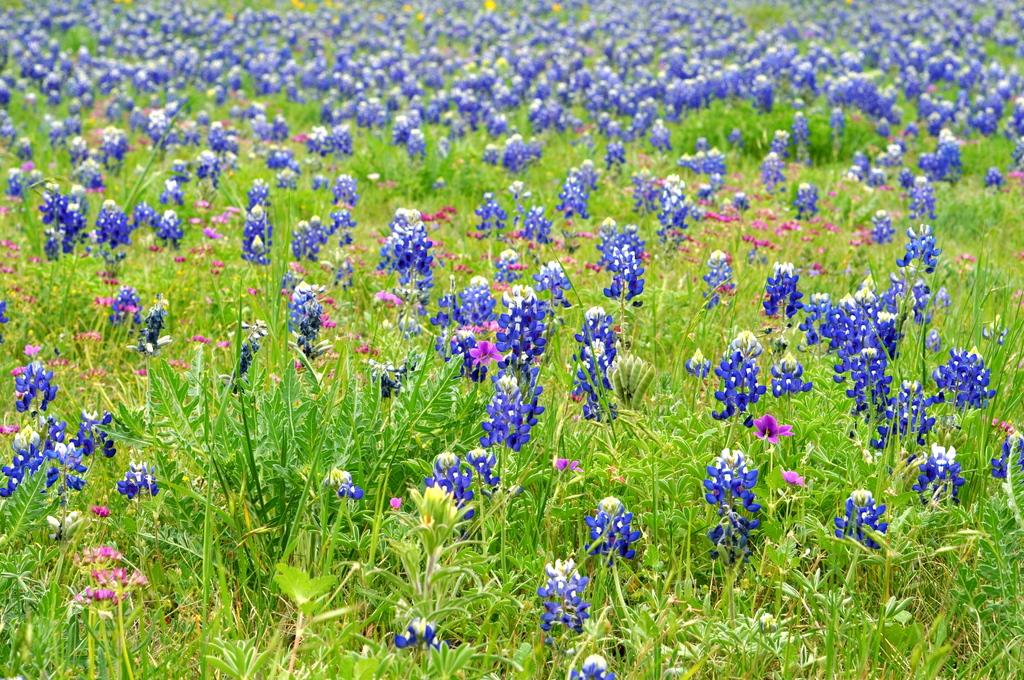What type of living organisms can be seen in the image? Plants and flowers are visible in the image. Can you describe the flowers in the image? The flowers in the image are part of the plants and add color and beauty to the scene. What type of humor can be found in the image? There is no humor present in the image, as it features plants and flowers. Can you explain how the plants and flowers are smashed in the image? The plants and flowers are not smashed in the image; they are shown in their natural state. 